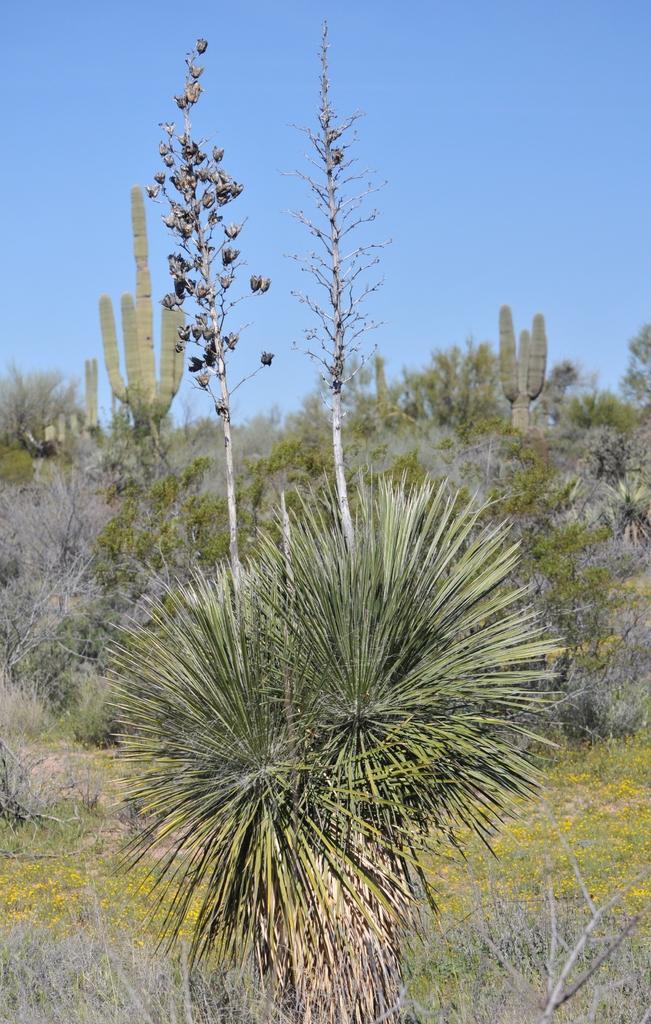Please provide a concise description of this image. In this image I can see few green and grey color trees. The sky is in blue color. 